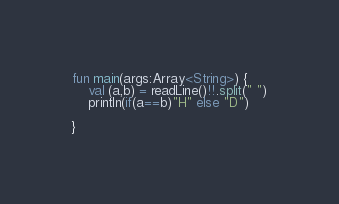Convert code to text. <code><loc_0><loc_0><loc_500><loc_500><_Kotlin_>fun main(args:Array<String>) {
	val (a,b) = readLine()!!.split(" ")
	println(if(a==b)"H" else "D")
	
}</code> 